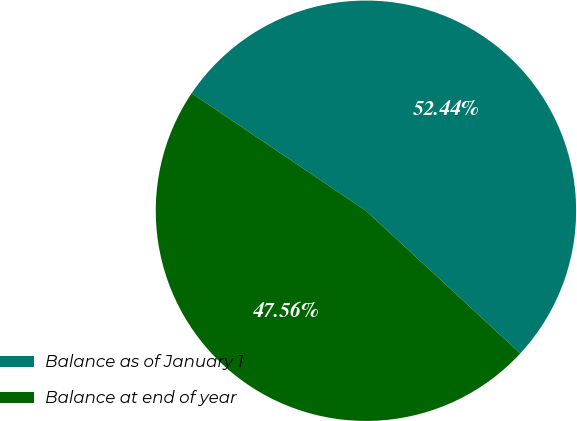<chart> <loc_0><loc_0><loc_500><loc_500><pie_chart><fcel>Balance as of January 1<fcel>Balance at end of year<nl><fcel>52.44%<fcel>47.56%<nl></chart> 